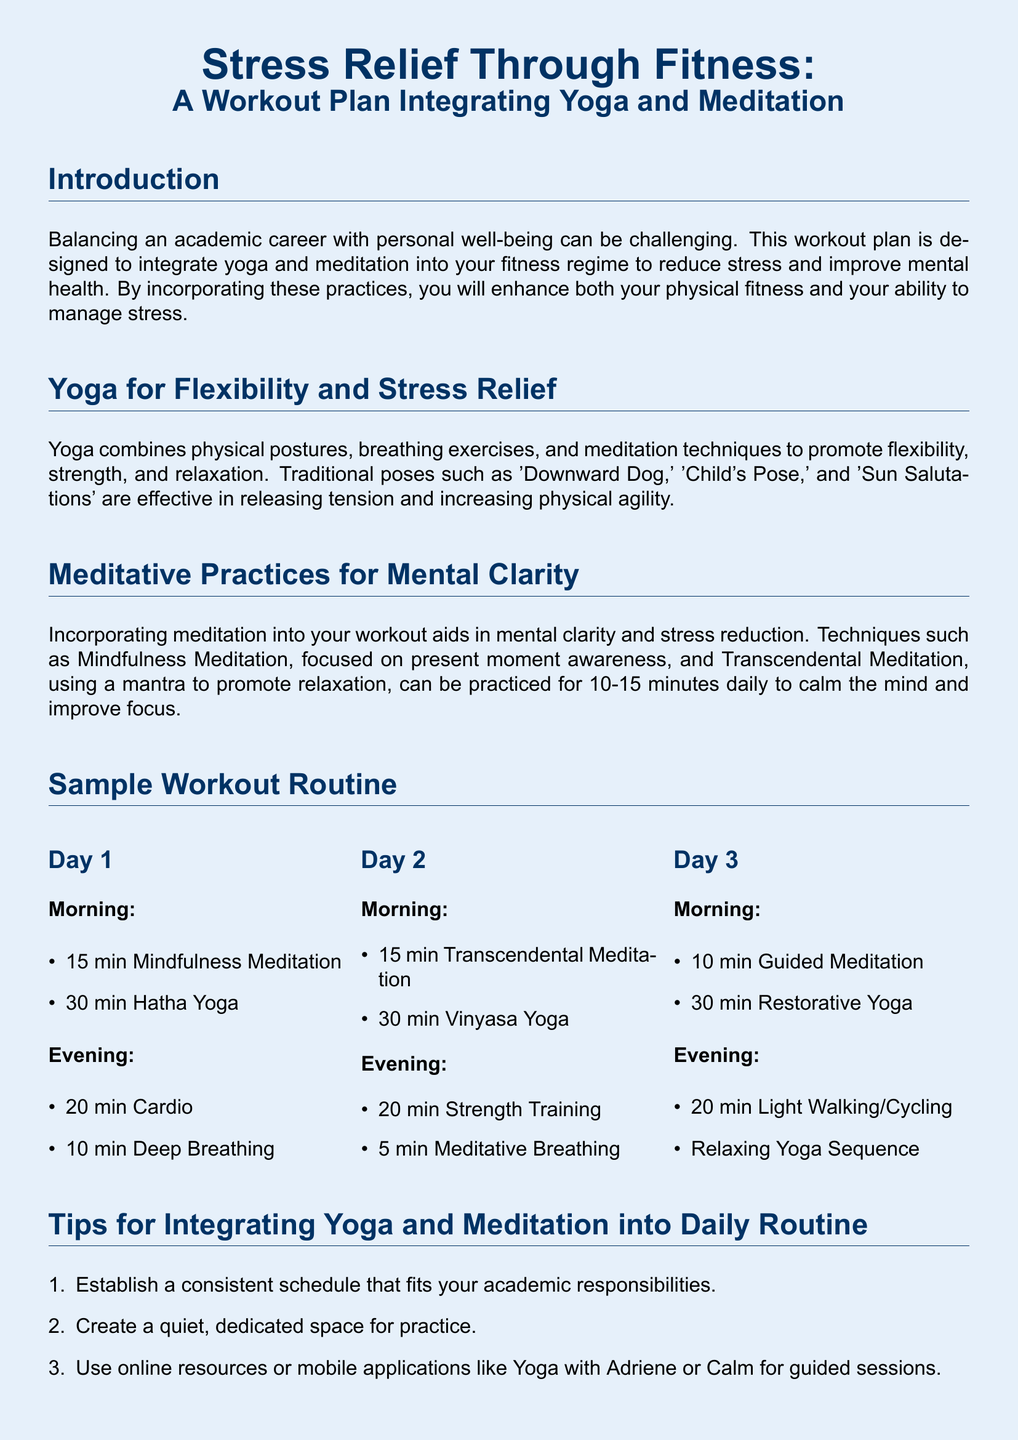What is the main focus of the workout plan? The main focus of the workout plan is to integrate yoga and meditation to reduce stress and improve mental health.
Answer: Integrate yoga and meditation How long should the meditation be practiced daily? The document suggests practicing meditation for 10-15 minutes daily to calm the mind and improve focus.
Answer: 10-15 minutes Name one traditional yoga pose mentioned. The document lists 'Downward Dog' as one of the traditional yoga poses effective in releasing tension.
Answer: Downward Dog What type of yoga is practiced on Day 2 morning? The type of yoga practiced on Day 2 morning is Vinyasa Yoga.
Answer: Vinyasa Yoga How many minutes are allocated for cardio in the evening of Day 1? The evening of Day 1 allocates 20 minutes for cardio.
Answer: 20 minutes List one tip for integrating yoga and meditation into a daily routine. The document provides several tips, one being to establish a consistent schedule that fits academic responsibilities.
Answer: Establish a consistent schedule What is the recommended action if you feel tired? The document advises listening to your body and taking rest days as needed if you feel tired.
Answer: Take rest days What is emphasized as key to maintaining balance between academic career and personal life? The document emphasizes consistency in integrating yoga and meditation as key to maintaining balance.
Answer: Consistency 